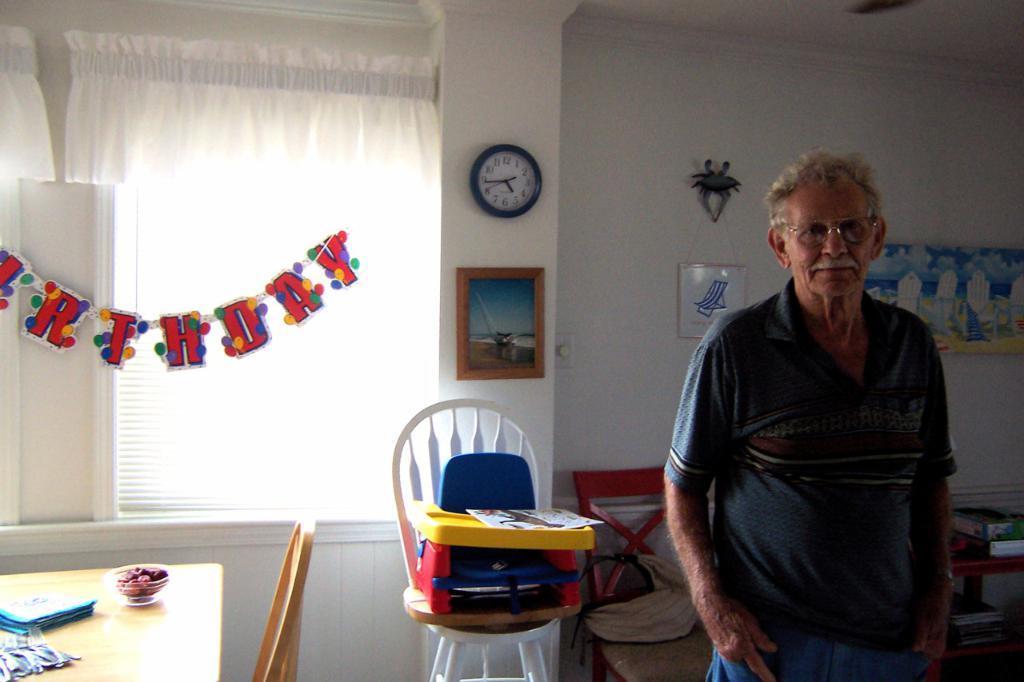Describe this image in one or two sentences. This picture shows a old man standing and wearing a spectacles. There is a table and a chair in the left side. In the background there is a chair on which some toys were placed. We can observe a curtain and a photo frame and a clock attached to the wall here. 